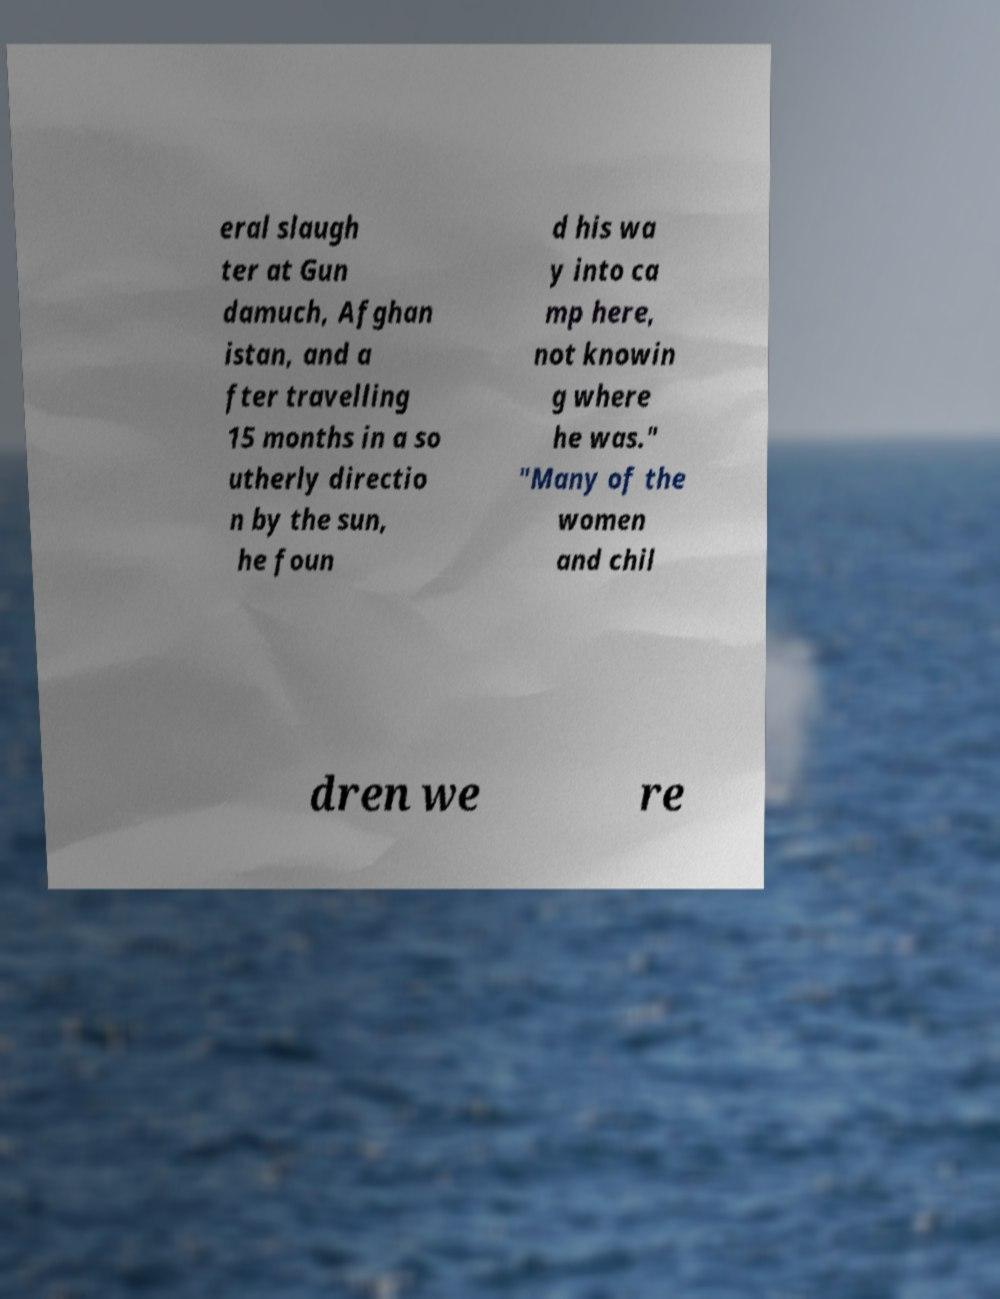What messages or text are displayed in this image? I need them in a readable, typed format. eral slaugh ter at Gun damuch, Afghan istan, and a fter travelling 15 months in a so utherly directio n by the sun, he foun d his wa y into ca mp here, not knowin g where he was." "Many of the women and chil dren we re 